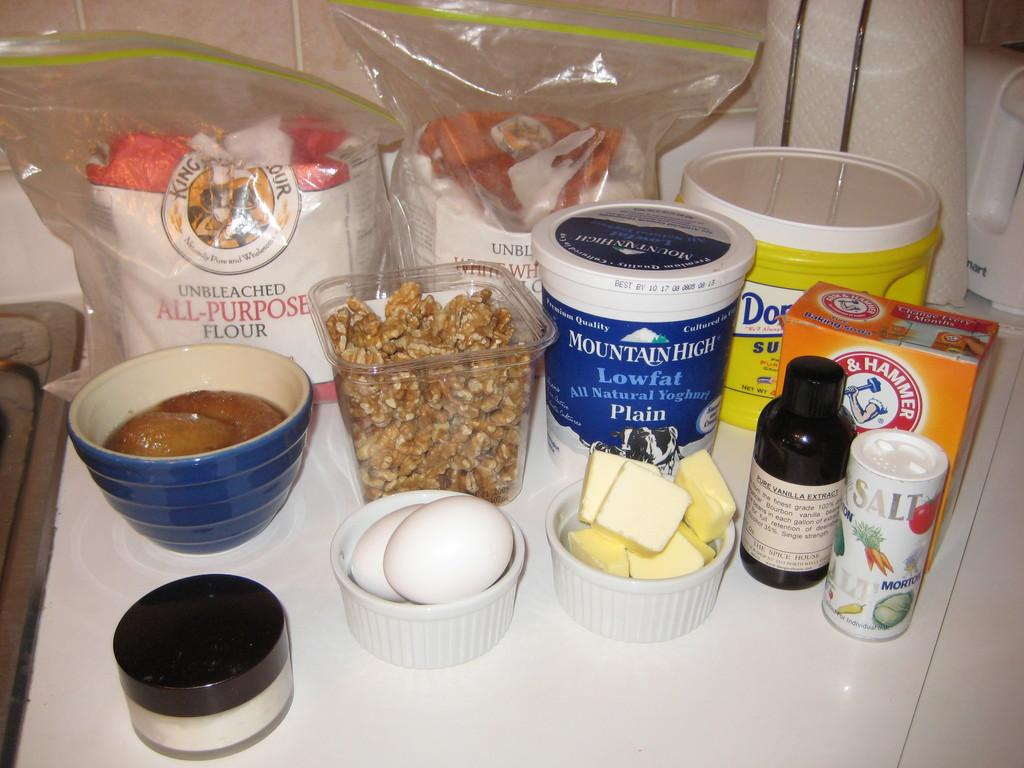What is located in the image that can hold food or other items? There is a bowl, a container, and boxes in the image that can hold food or other items. What type of food can be seen in the image? There are eggs and cheese in the image. What type of covers are present in the image? There are covers in the image. What is the color of the table in the image? The table in the image is white. In which direction are the eggs facing in the image? The direction in which the eggs are facing cannot be determined from the image, as they are not shown to have a specific orientation. What type of quartz is present in the image? There is no quartz present in the image. What type of oatmeal can be seen in the image? There is no oatmeal present in the image. 